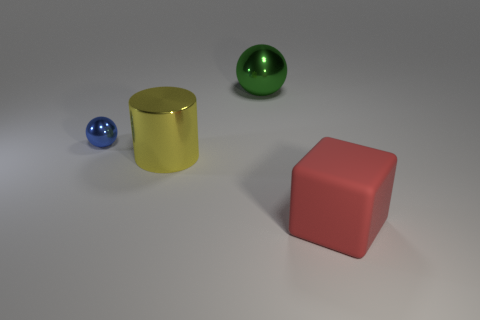There is a sphere that is the same size as the yellow metallic thing; what material is it?
Your answer should be compact. Metal. How many matte objects are either brown balls or tiny objects?
Make the answer very short. 0. What color is the object that is both right of the large cylinder and behind the cylinder?
Keep it short and to the point. Green. How many large yellow cylinders are behind the tiny blue thing?
Your answer should be compact. 0. What material is the big ball?
Offer a very short reply. Metal. There is a sphere in front of the metal thing that is behind the metallic thing that is left of the cylinder; what color is it?
Offer a terse response. Blue. What number of blue blocks have the same size as the yellow cylinder?
Ensure brevity in your answer.  0. The thing to the right of the green shiny sphere is what color?
Offer a very short reply. Red. How many other things are there of the same size as the green thing?
Provide a succinct answer. 2. There is a thing that is both right of the small blue sphere and behind the cylinder; how big is it?
Your answer should be compact. Large. 